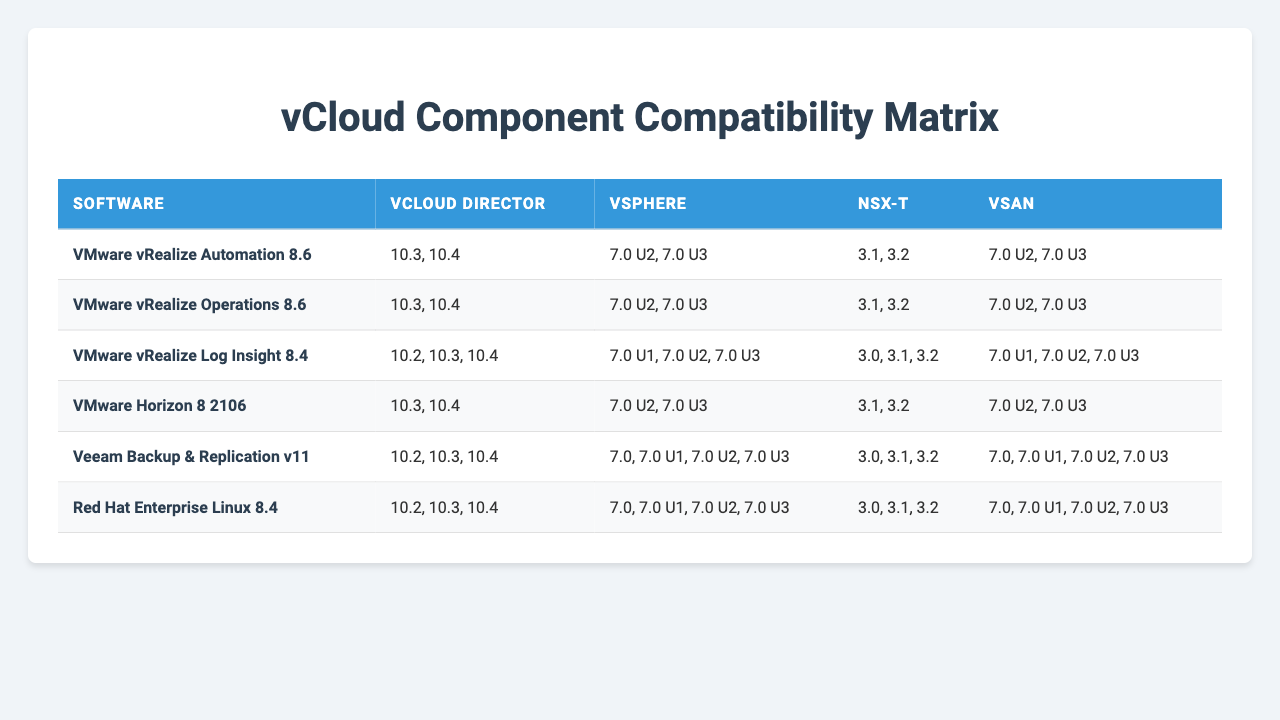What software versions are compatible with vCloud Director 10.3? According to the table, the software versions compatible with vCloud Director 10.3 are VMware vRealize Automation 8.6, VMware vRealize Operations 8.6, VMware Horizon 8 2106, VMware vRealize Log Insight 8.4, Veeam Backup & Replication v11, and Red Hat Enterprise Linux 8.4.
Answer: VMware vRealize Automation 8.6, VMware vRealize Operations 8.6, VMware Horizon 8 2106, VMware vRealize Log Insight 8.4, Veeam Backup & Replication v11, Red Hat Enterprise Linux 8.4 Is VMware Horizon 8 2106 compatible with vSAN 7.0 U2? The table shows that VMware Horizon 8 2106 is listed under vSAN with compatible versions including 7.0 U2.
Answer: Yes What is the maximum version of vSphere supported by VMware vRealize Log Insight 8.4? The table indicates that the compatible versions for vSphere with VMware vRealize Log Insight 8.4 are 7.0 U1, 7.0 U2, and 7.0 U3. Therefore, the maximum version is 7.0 U3.
Answer: 7.0 U3 How many software options are compatible with NSX-T 3.1? From the table, the software options compatible with NSX-T 3.1 are VMware vRealize Automation 8.6, VMware vRealize Operations 8.6, VMware Horizon 8 2106, VMware vRealize Log Insight 8.4, Veeam Backup & Replication v11, and Red Hat Enterprise Linux 8.4, totaling six.
Answer: 6 Which software is compatible with both vCloud Director 10.2 and vSAN 7.0? By examining the table, both Veeam Backup & Replication v11 and Red Hat Enterprise Linux 8.4 are compatible with vCloud Director 10.2 and vSAN 7.0.
Answer: Veeam Backup & Replication v11, Red Hat Enterprise Linux 8.4 What versions of vCloud Director are supported by VMware vRealize Automation 8.6? According to the table, VMware vRealize Automation 8.6 supports vCloud Director versions 10.3 and 10.4.
Answer: 10.3, 10.4 Is there any software that does not support vSphere 7.0 U2? By checking the table, all listed software supports vSphere 7.0 U2, hence there is no software that does not.
Answer: No How many vCloud Director versions support VMware vRealize Operations 8.6? The table shows that VMware vRealize Operations 8.6 is compatible with vCloud Director versions 10.3 and 10.4, making it two versions in total.
Answer: 2 Which software has the widest range of compatible vSphere versions? Veeam Backup & Replication v11 and Red Hat Enterprise Linux 8.4 both support versions: 7.0, 7.0 U1, 7.0 U2, and 7.0 U3, giving them a total of four versions.
Answer: Veeam Backup & Replication v11, Red Hat Enterprise Linux 8.4 What is the common NSX-T version compatible with all listed software? The common NSX-T versions for most software from the table are 3.1 and 3.2, but they are not commonly compatible across all, indicating the software varies.
Answer: None 